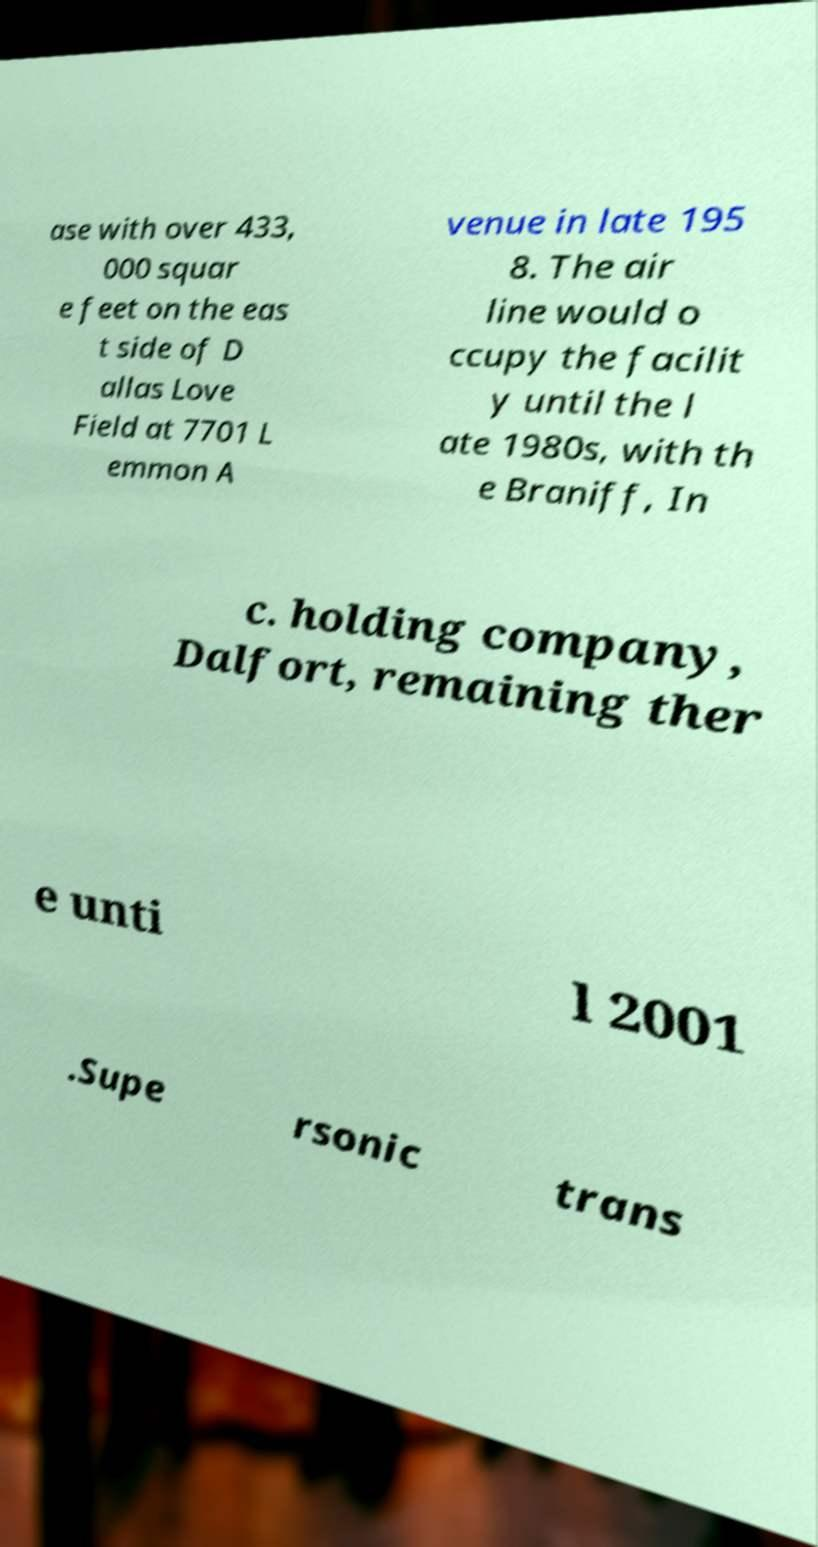I need the written content from this picture converted into text. Can you do that? ase with over 433, 000 squar e feet on the eas t side of D allas Love Field at 7701 L emmon A venue in late 195 8. The air line would o ccupy the facilit y until the l ate 1980s, with th e Braniff, In c. holding company, Dalfort, remaining ther e unti l 2001 .Supe rsonic trans 